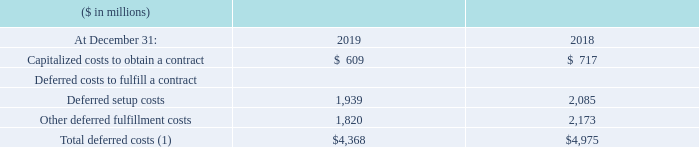(1) Of the total deferred costs, $1,896 million was current and $2,472 million was noncurrent at December 31, 2019 and $2,300 million was current and $2,676 million was noncurrent at December 31, 2018.
The amount of total deferred costs amortized during the year ended December 31, 2019 was $3,836 million and there were no material impairment losses incurred. Refer to note A, “Significant Accounting Policies,” for additional information on deferred costs to fulfill a contract and capitalized costs of obtaining a contract.
What is the current and noncurrent total deferred costs for 2019? $1,896 million was current and $2,472 million was noncurrent at december 31, 2019. What is the current and noncurrent total deferred costs for 2018? $2,300 million was current and $2,676 million was noncurrent at december 31, 2018. What is the total deferred costs amortized during 2019? $3,836 million. What is the increase/ (decrease) in Capitalized costs to obtain a contract from 2018 to 2019
Answer scale should be: million. 609-717
Answer: -108. What is the average of Capitalized costs to obtain a contract?
Answer scale should be: million. (609+717) / 2
Answer: 663. What is the average of Deferred setup costs?
Answer scale should be: million. (1,939 +2,085) / 2
Answer: 2012. 